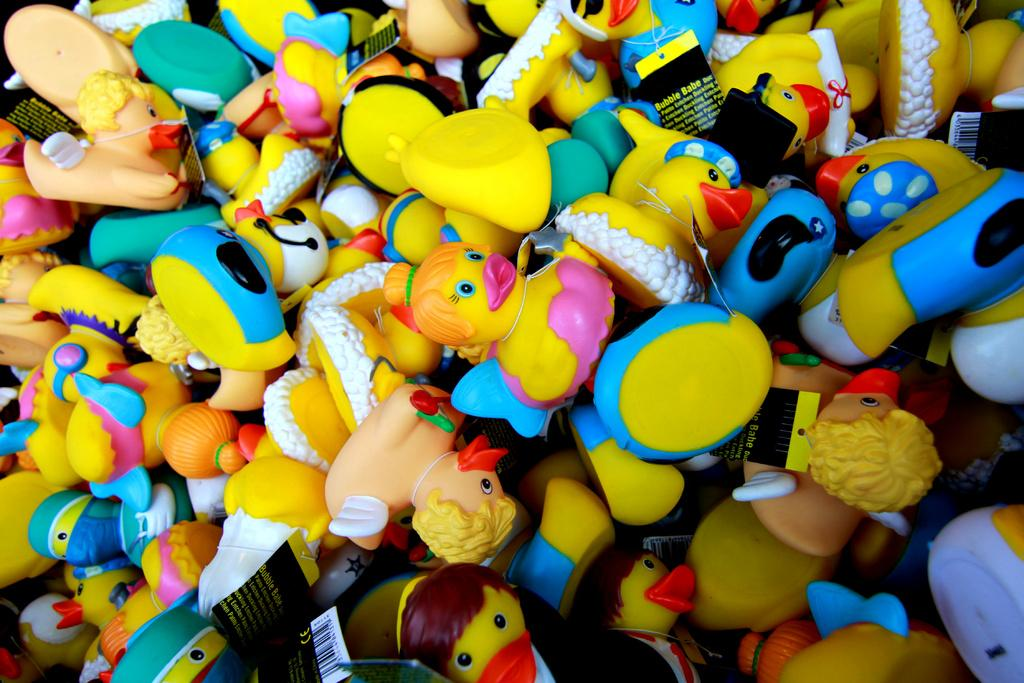What is the main subject of the image? The main subject of the image is a group of dolls. Can you describe the dolls in the image? Unfortunately, the facts provided do not give any details about the appearance or characteristics of the dolls. Are there any other objects or figures in the image besides the dolls? No, the facts provided only mention the presence of a group of dolls in the image. What type of feather can be seen on the branch in the image? There is no mention of a feather or a branch in the image. The image only contains a group of dolls. 